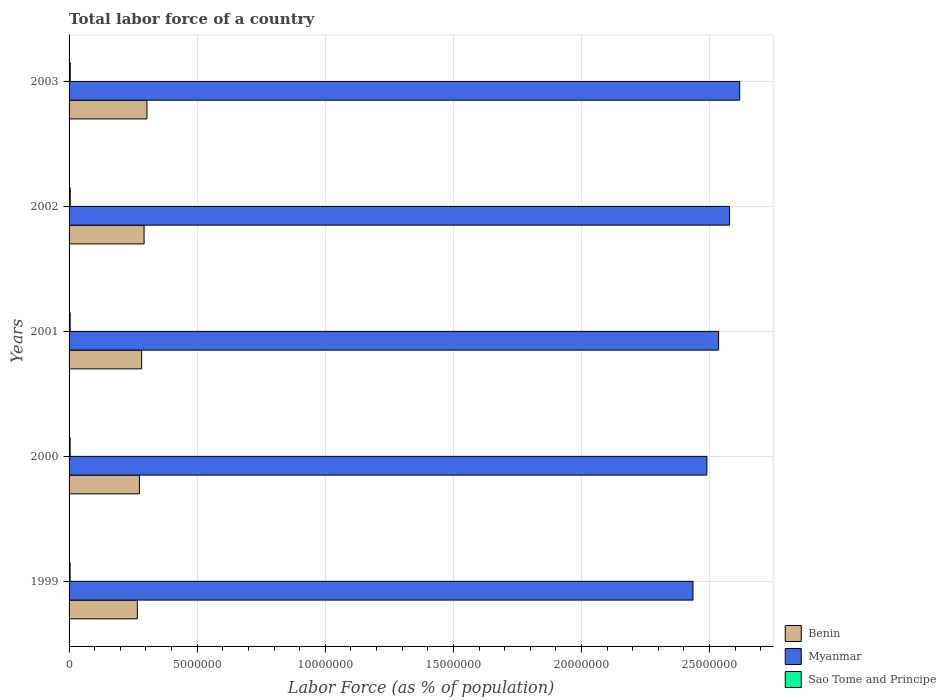How many different coloured bars are there?
Offer a very short reply. 3. How many groups of bars are there?
Offer a very short reply. 5. How many bars are there on the 1st tick from the top?
Provide a short and direct response. 3. What is the label of the 1st group of bars from the top?
Give a very brief answer. 2003. What is the percentage of labor force in Myanmar in 2002?
Ensure brevity in your answer.  2.58e+07. Across all years, what is the maximum percentage of labor force in Sao Tome and Principe?
Give a very brief answer. 4.64e+04. Across all years, what is the minimum percentage of labor force in Myanmar?
Your response must be concise. 2.44e+07. In which year was the percentage of labor force in Benin maximum?
Offer a terse response. 2003. What is the total percentage of labor force in Sao Tome and Principe in the graph?
Your response must be concise. 2.18e+05. What is the difference between the percentage of labor force in Sao Tome and Principe in 1999 and that in 2000?
Your answer should be very brief. -957. What is the difference between the percentage of labor force in Benin in 2001 and the percentage of labor force in Myanmar in 2002?
Keep it short and to the point. -2.29e+07. What is the average percentage of labor force in Sao Tome and Principe per year?
Provide a succinct answer. 4.35e+04. In the year 2001, what is the difference between the percentage of labor force in Benin and percentage of labor force in Myanmar?
Make the answer very short. -2.25e+07. What is the ratio of the percentage of labor force in Myanmar in 2000 to that in 2003?
Provide a short and direct response. 0.95. Is the difference between the percentage of labor force in Benin in 1999 and 2001 greater than the difference between the percentage of labor force in Myanmar in 1999 and 2001?
Your response must be concise. Yes. What is the difference between the highest and the second highest percentage of labor force in Sao Tome and Principe?
Provide a succinct answer. 1702. What is the difference between the highest and the lowest percentage of labor force in Myanmar?
Provide a short and direct response. 1.82e+06. Is the sum of the percentage of labor force in Sao Tome and Principe in 2000 and 2003 greater than the maximum percentage of labor force in Benin across all years?
Your response must be concise. No. What does the 2nd bar from the top in 2002 represents?
Keep it short and to the point. Myanmar. What does the 1st bar from the bottom in 2001 represents?
Provide a short and direct response. Benin. Is it the case that in every year, the sum of the percentage of labor force in Sao Tome and Principe and percentage of labor force in Myanmar is greater than the percentage of labor force in Benin?
Your response must be concise. Yes. How many years are there in the graph?
Give a very brief answer. 5. Does the graph contain grids?
Offer a terse response. Yes. How many legend labels are there?
Keep it short and to the point. 3. What is the title of the graph?
Ensure brevity in your answer.  Total labor force of a country. What is the label or title of the X-axis?
Make the answer very short. Labor Force (as % of population). What is the label or title of the Y-axis?
Give a very brief answer. Years. What is the Labor Force (as % of population) in Benin in 1999?
Provide a short and direct response. 2.66e+06. What is the Labor Force (as % of population) in Myanmar in 1999?
Your answer should be compact. 2.44e+07. What is the Labor Force (as % of population) of Sao Tome and Principe in 1999?
Provide a short and direct response. 4.11e+04. What is the Labor Force (as % of population) of Benin in 2000?
Keep it short and to the point. 2.75e+06. What is the Labor Force (as % of population) of Myanmar in 2000?
Your answer should be very brief. 2.49e+07. What is the Labor Force (as % of population) in Sao Tome and Principe in 2000?
Your answer should be compact. 4.21e+04. What is the Labor Force (as % of population) in Benin in 2001?
Ensure brevity in your answer.  2.83e+06. What is the Labor Force (as % of population) of Myanmar in 2001?
Keep it short and to the point. 2.54e+07. What is the Labor Force (as % of population) in Sao Tome and Principe in 2001?
Your answer should be very brief. 4.32e+04. What is the Labor Force (as % of population) of Benin in 2002?
Your response must be concise. 2.93e+06. What is the Labor Force (as % of population) in Myanmar in 2002?
Provide a short and direct response. 2.58e+07. What is the Labor Force (as % of population) of Sao Tome and Principe in 2002?
Make the answer very short. 4.47e+04. What is the Labor Force (as % of population) of Benin in 2003?
Your answer should be very brief. 3.04e+06. What is the Labor Force (as % of population) in Myanmar in 2003?
Keep it short and to the point. 2.62e+07. What is the Labor Force (as % of population) in Sao Tome and Principe in 2003?
Keep it short and to the point. 4.64e+04. Across all years, what is the maximum Labor Force (as % of population) in Benin?
Keep it short and to the point. 3.04e+06. Across all years, what is the maximum Labor Force (as % of population) in Myanmar?
Keep it short and to the point. 2.62e+07. Across all years, what is the maximum Labor Force (as % of population) of Sao Tome and Principe?
Your answer should be compact. 4.64e+04. Across all years, what is the minimum Labor Force (as % of population) in Benin?
Provide a succinct answer. 2.66e+06. Across all years, what is the minimum Labor Force (as % of population) of Myanmar?
Give a very brief answer. 2.44e+07. Across all years, what is the minimum Labor Force (as % of population) of Sao Tome and Principe?
Provide a succinct answer. 4.11e+04. What is the total Labor Force (as % of population) of Benin in the graph?
Make the answer very short. 1.42e+07. What is the total Labor Force (as % of population) of Myanmar in the graph?
Your answer should be very brief. 1.27e+08. What is the total Labor Force (as % of population) of Sao Tome and Principe in the graph?
Ensure brevity in your answer.  2.18e+05. What is the difference between the Labor Force (as % of population) of Benin in 1999 and that in 2000?
Your answer should be very brief. -8.17e+04. What is the difference between the Labor Force (as % of population) in Myanmar in 1999 and that in 2000?
Offer a very short reply. -5.42e+05. What is the difference between the Labor Force (as % of population) in Sao Tome and Principe in 1999 and that in 2000?
Provide a short and direct response. -957. What is the difference between the Labor Force (as % of population) of Benin in 1999 and that in 2001?
Ensure brevity in your answer.  -1.69e+05. What is the difference between the Labor Force (as % of population) in Myanmar in 1999 and that in 2001?
Your response must be concise. -1.00e+06. What is the difference between the Labor Force (as % of population) in Sao Tome and Principe in 1999 and that in 2001?
Your response must be concise. -2080. What is the difference between the Labor Force (as % of population) of Benin in 1999 and that in 2002?
Give a very brief answer. -2.64e+05. What is the difference between the Labor Force (as % of population) of Myanmar in 1999 and that in 2002?
Offer a very short reply. -1.43e+06. What is the difference between the Labor Force (as % of population) of Sao Tome and Principe in 1999 and that in 2002?
Offer a very short reply. -3577. What is the difference between the Labor Force (as % of population) of Benin in 1999 and that in 2003?
Your answer should be compact. -3.77e+05. What is the difference between the Labor Force (as % of population) in Myanmar in 1999 and that in 2003?
Provide a short and direct response. -1.82e+06. What is the difference between the Labor Force (as % of population) in Sao Tome and Principe in 1999 and that in 2003?
Your response must be concise. -5279. What is the difference between the Labor Force (as % of population) in Benin in 2000 and that in 2001?
Ensure brevity in your answer.  -8.73e+04. What is the difference between the Labor Force (as % of population) in Myanmar in 2000 and that in 2001?
Keep it short and to the point. -4.58e+05. What is the difference between the Labor Force (as % of population) in Sao Tome and Principe in 2000 and that in 2001?
Your answer should be compact. -1123. What is the difference between the Labor Force (as % of population) in Benin in 2000 and that in 2002?
Provide a succinct answer. -1.82e+05. What is the difference between the Labor Force (as % of population) of Myanmar in 2000 and that in 2002?
Provide a short and direct response. -8.85e+05. What is the difference between the Labor Force (as % of population) in Sao Tome and Principe in 2000 and that in 2002?
Ensure brevity in your answer.  -2620. What is the difference between the Labor Force (as % of population) of Benin in 2000 and that in 2003?
Offer a very short reply. -2.95e+05. What is the difference between the Labor Force (as % of population) in Myanmar in 2000 and that in 2003?
Offer a very short reply. -1.28e+06. What is the difference between the Labor Force (as % of population) in Sao Tome and Principe in 2000 and that in 2003?
Offer a very short reply. -4322. What is the difference between the Labor Force (as % of population) in Benin in 2001 and that in 2002?
Provide a short and direct response. -9.46e+04. What is the difference between the Labor Force (as % of population) of Myanmar in 2001 and that in 2002?
Offer a very short reply. -4.27e+05. What is the difference between the Labor Force (as % of population) of Sao Tome and Principe in 2001 and that in 2002?
Keep it short and to the point. -1497. What is the difference between the Labor Force (as % of population) of Benin in 2001 and that in 2003?
Ensure brevity in your answer.  -2.08e+05. What is the difference between the Labor Force (as % of population) in Myanmar in 2001 and that in 2003?
Your answer should be very brief. -8.24e+05. What is the difference between the Labor Force (as % of population) of Sao Tome and Principe in 2001 and that in 2003?
Your answer should be compact. -3199. What is the difference between the Labor Force (as % of population) of Benin in 2002 and that in 2003?
Keep it short and to the point. -1.13e+05. What is the difference between the Labor Force (as % of population) of Myanmar in 2002 and that in 2003?
Your answer should be very brief. -3.97e+05. What is the difference between the Labor Force (as % of population) of Sao Tome and Principe in 2002 and that in 2003?
Your answer should be very brief. -1702. What is the difference between the Labor Force (as % of population) of Benin in 1999 and the Labor Force (as % of population) of Myanmar in 2000?
Make the answer very short. -2.22e+07. What is the difference between the Labor Force (as % of population) in Benin in 1999 and the Labor Force (as % of population) in Sao Tome and Principe in 2000?
Keep it short and to the point. 2.62e+06. What is the difference between the Labor Force (as % of population) of Myanmar in 1999 and the Labor Force (as % of population) of Sao Tome and Principe in 2000?
Ensure brevity in your answer.  2.43e+07. What is the difference between the Labor Force (as % of population) of Benin in 1999 and the Labor Force (as % of population) of Myanmar in 2001?
Your answer should be compact. -2.27e+07. What is the difference between the Labor Force (as % of population) in Benin in 1999 and the Labor Force (as % of population) in Sao Tome and Principe in 2001?
Offer a terse response. 2.62e+06. What is the difference between the Labor Force (as % of population) of Myanmar in 1999 and the Labor Force (as % of population) of Sao Tome and Principe in 2001?
Give a very brief answer. 2.43e+07. What is the difference between the Labor Force (as % of population) of Benin in 1999 and the Labor Force (as % of population) of Myanmar in 2002?
Your answer should be compact. -2.31e+07. What is the difference between the Labor Force (as % of population) in Benin in 1999 and the Labor Force (as % of population) in Sao Tome and Principe in 2002?
Ensure brevity in your answer.  2.62e+06. What is the difference between the Labor Force (as % of population) in Myanmar in 1999 and the Labor Force (as % of population) in Sao Tome and Principe in 2002?
Ensure brevity in your answer.  2.43e+07. What is the difference between the Labor Force (as % of population) of Benin in 1999 and the Labor Force (as % of population) of Myanmar in 2003?
Give a very brief answer. -2.35e+07. What is the difference between the Labor Force (as % of population) of Benin in 1999 and the Labor Force (as % of population) of Sao Tome and Principe in 2003?
Provide a succinct answer. 2.62e+06. What is the difference between the Labor Force (as % of population) of Myanmar in 1999 and the Labor Force (as % of population) of Sao Tome and Principe in 2003?
Your response must be concise. 2.43e+07. What is the difference between the Labor Force (as % of population) in Benin in 2000 and the Labor Force (as % of population) in Myanmar in 2001?
Provide a short and direct response. -2.26e+07. What is the difference between the Labor Force (as % of population) of Benin in 2000 and the Labor Force (as % of population) of Sao Tome and Principe in 2001?
Your response must be concise. 2.70e+06. What is the difference between the Labor Force (as % of population) of Myanmar in 2000 and the Labor Force (as % of population) of Sao Tome and Principe in 2001?
Keep it short and to the point. 2.49e+07. What is the difference between the Labor Force (as % of population) of Benin in 2000 and the Labor Force (as % of population) of Myanmar in 2002?
Your response must be concise. -2.30e+07. What is the difference between the Labor Force (as % of population) of Benin in 2000 and the Labor Force (as % of population) of Sao Tome and Principe in 2002?
Your response must be concise. 2.70e+06. What is the difference between the Labor Force (as % of population) of Myanmar in 2000 and the Labor Force (as % of population) of Sao Tome and Principe in 2002?
Your answer should be compact. 2.48e+07. What is the difference between the Labor Force (as % of population) of Benin in 2000 and the Labor Force (as % of population) of Myanmar in 2003?
Offer a terse response. -2.34e+07. What is the difference between the Labor Force (as % of population) in Benin in 2000 and the Labor Force (as % of population) in Sao Tome and Principe in 2003?
Ensure brevity in your answer.  2.70e+06. What is the difference between the Labor Force (as % of population) of Myanmar in 2000 and the Labor Force (as % of population) of Sao Tome and Principe in 2003?
Make the answer very short. 2.48e+07. What is the difference between the Labor Force (as % of population) of Benin in 2001 and the Labor Force (as % of population) of Myanmar in 2002?
Offer a very short reply. -2.29e+07. What is the difference between the Labor Force (as % of population) of Benin in 2001 and the Labor Force (as % of population) of Sao Tome and Principe in 2002?
Give a very brief answer. 2.79e+06. What is the difference between the Labor Force (as % of population) in Myanmar in 2001 and the Labor Force (as % of population) in Sao Tome and Principe in 2002?
Your response must be concise. 2.53e+07. What is the difference between the Labor Force (as % of population) in Benin in 2001 and the Labor Force (as % of population) in Myanmar in 2003?
Give a very brief answer. -2.33e+07. What is the difference between the Labor Force (as % of population) of Benin in 2001 and the Labor Force (as % of population) of Sao Tome and Principe in 2003?
Make the answer very short. 2.79e+06. What is the difference between the Labor Force (as % of population) in Myanmar in 2001 and the Labor Force (as % of population) in Sao Tome and Principe in 2003?
Provide a short and direct response. 2.53e+07. What is the difference between the Labor Force (as % of population) in Benin in 2002 and the Labor Force (as % of population) in Myanmar in 2003?
Give a very brief answer. -2.32e+07. What is the difference between the Labor Force (as % of population) of Benin in 2002 and the Labor Force (as % of population) of Sao Tome and Principe in 2003?
Keep it short and to the point. 2.88e+06. What is the difference between the Labor Force (as % of population) of Myanmar in 2002 and the Labor Force (as % of population) of Sao Tome and Principe in 2003?
Offer a terse response. 2.57e+07. What is the average Labor Force (as % of population) in Benin per year?
Your answer should be very brief. 2.84e+06. What is the average Labor Force (as % of population) in Myanmar per year?
Provide a succinct answer. 2.53e+07. What is the average Labor Force (as % of population) in Sao Tome and Principe per year?
Offer a terse response. 4.35e+04. In the year 1999, what is the difference between the Labor Force (as % of population) of Benin and Labor Force (as % of population) of Myanmar?
Give a very brief answer. -2.17e+07. In the year 1999, what is the difference between the Labor Force (as % of population) in Benin and Labor Force (as % of population) in Sao Tome and Principe?
Provide a succinct answer. 2.62e+06. In the year 1999, what is the difference between the Labor Force (as % of population) in Myanmar and Labor Force (as % of population) in Sao Tome and Principe?
Make the answer very short. 2.43e+07. In the year 2000, what is the difference between the Labor Force (as % of population) in Benin and Labor Force (as % of population) in Myanmar?
Offer a terse response. -2.21e+07. In the year 2000, what is the difference between the Labor Force (as % of population) in Benin and Labor Force (as % of population) in Sao Tome and Principe?
Your response must be concise. 2.70e+06. In the year 2000, what is the difference between the Labor Force (as % of population) of Myanmar and Labor Force (as % of population) of Sao Tome and Principe?
Provide a succinct answer. 2.49e+07. In the year 2001, what is the difference between the Labor Force (as % of population) in Benin and Labor Force (as % of population) in Myanmar?
Give a very brief answer. -2.25e+07. In the year 2001, what is the difference between the Labor Force (as % of population) in Benin and Labor Force (as % of population) in Sao Tome and Principe?
Your answer should be compact. 2.79e+06. In the year 2001, what is the difference between the Labor Force (as % of population) in Myanmar and Labor Force (as % of population) in Sao Tome and Principe?
Give a very brief answer. 2.53e+07. In the year 2002, what is the difference between the Labor Force (as % of population) in Benin and Labor Force (as % of population) in Myanmar?
Ensure brevity in your answer.  -2.29e+07. In the year 2002, what is the difference between the Labor Force (as % of population) of Benin and Labor Force (as % of population) of Sao Tome and Principe?
Your answer should be compact. 2.88e+06. In the year 2002, what is the difference between the Labor Force (as % of population) of Myanmar and Labor Force (as % of population) of Sao Tome and Principe?
Ensure brevity in your answer.  2.57e+07. In the year 2003, what is the difference between the Labor Force (as % of population) of Benin and Labor Force (as % of population) of Myanmar?
Your response must be concise. -2.31e+07. In the year 2003, what is the difference between the Labor Force (as % of population) in Benin and Labor Force (as % of population) in Sao Tome and Principe?
Keep it short and to the point. 2.99e+06. In the year 2003, what is the difference between the Labor Force (as % of population) of Myanmar and Labor Force (as % of population) of Sao Tome and Principe?
Offer a very short reply. 2.61e+07. What is the ratio of the Labor Force (as % of population) in Benin in 1999 to that in 2000?
Provide a succinct answer. 0.97. What is the ratio of the Labor Force (as % of population) of Myanmar in 1999 to that in 2000?
Offer a terse response. 0.98. What is the ratio of the Labor Force (as % of population) of Sao Tome and Principe in 1999 to that in 2000?
Give a very brief answer. 0.98. What is the ratio of the Labor Force (as % of population) of Benin in 1999 to that in 2001?
Offer a terse response. 0.94. What is the ratio of the Labor Force (as % of population) in Myanmar in 1999 to that in 2001?
Your answer should be very brief. 0.96. What is the ratio of the Labor Force (as % of population) in Sao Tome and Principe in 1999 to that in 2001?
Offer a very short reply. 0.95. What is the ratio of the Labor Force (as % of population) of Benin in 1999 to that in 2002?
Offer a terse response. 0.91. What is the ratio of the Labor Force (as % of population) in Myanmar in 1999 to that in 2002?
Your answer should be very brief. 0.94. What is the ratio of the Labor Force (as % of population) in Sao Tome and Principe in 1999 to that in 2002?
Your response must be concise. 0.92. What is the ratio of the Labor Force (as % of population) in Benin in 1999 to that in 2003?
Your response must be concise. 0.88. What is the ratio of the Labor Force (as % of population) of Myanmar in 1999 to that in 2003?
Your response must be concise. 0.93. What is the ratio of the Labor Force (as % of population) of Sao Tome and Principe in 1999 to that in 2003?
Your response must be concise. 0.89. What is the ratio of the Labor Force (as % of population) of Benin in 2000 to that in 2001?
Your answer should be very brief. 0.97. What is the ratio of the Labor Force (as % of population) in Myanmar in 2000 to that in 2001?
Offer a very short reply. 0.98. What is the ratio of the Labor Force (as % of population) of Benin in 2000 to that in 2002?
Your answer should be compact. 0.94. What is the ratio of the Labor Force (as % of population) of Myanmar in 2000 to that in 2002?
Your answer should be very brief. 0.97. What is the ratio of the Labor Force (as % of population) in Sao Tome and Principe in 2000 to that in 2002?
Provide a short and direct response. 0.94. What is the ratio of the Labor Force (as % of population) of Benin in 2000 to that in 2003?
Keep it short and to the point. 0.9. What is the ratio of the Labor Force (as % of population) in Myanmar in 2000 to that in 2003?
Provide a succinct answer. 0.95. What is the ratio of the Labor Force (as % of population) in Sao Tome and Principe in 2000 to that in 2003?
Your answer should be compact. 0.91. What is the ratio of the Labor Force (as % of population) in Myanmar in 2001 to that in 2002?
Offer a terse response. 0.98. What is the ratio of the Labor Force (as % of population) of Sao Tome and Principe in 2001 to that in 2002?
Offer a very short reply. 0.97. What is the ratio of the Labor Force (as % of population) in Benin in 2001 to that in 2003?
Your answer should be very brief. 0.93. What is the ratio of the Labor Force (as % of population) in Myanmar in 2001 to that in 2003?
Your answer should be compact. 0.97. What is the ratio of the Labor Force (as % of population) of Sao Tome and Principe in 2001 to that in 2003?
Your response must be concise. 0.93. What is the ratio of the Labor Force (as % of population) of Benin in 2002 to that in 2003?
Offer a very short reply. 0.96. What is the ratio of the Labor Force (as % of population) in Myanmar in 2002 to that in 2003?
Provide a succinct answer. 0.98. What is the ratio of the Labor Force (as % of population) of Sao Tome and Principe in 2002 to that in 2003?
Keep it short and to the point. 0.96. What is the difference between the highest and the second highest Labor Force (as % of population) of Benin?
Your answer should be very brief. 1.13e+05. What is the difference between the highest and the second highest Labor Force (as % of population) of Myanmar?
Ensure brevity in your answer.  3.97e+05. What is the difference between the highest and the second highest Labor Force (as % of population) of Sao Tome and Principe?
Your response must be concise. 1702. What is the difference between the highest and the lowest Labor Force (as % of population) in Benin?
Offer a terse response. 3.77e+05. What is the difference between the highest and the lowest Labor Force (as % of population) of Myanmar?
Keep it short and to the point. 1.82e+06. What is the difference between the highest and the lowest Labor Force (as % of population) of Sao Tome and Principe?
Your answer should be very brief. 5279. 